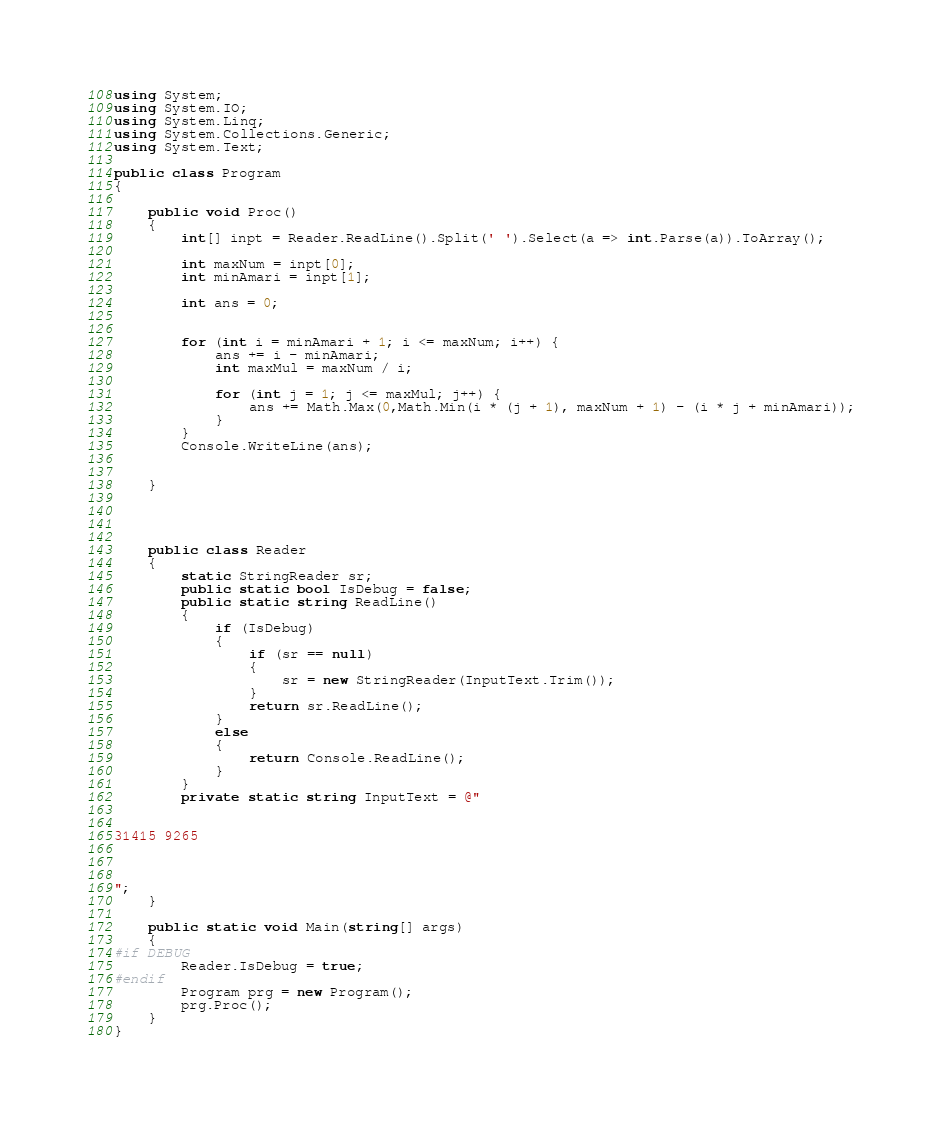<code> <loc_0><loc_0><loc_500><loc_500><_C#_>using System;
using System.IO;
using System.Linq;
using System.Collections.Generic;
using System.Text;

public class Program
{

    public void Proc()
    {
        int[] inpt = Reader.ReadLine().Split(' ').Select(a => int.Parse(a)).ToArray();

        int maxNum = inpt[0];
        int minAmari = inpt[1];

        int ans = 0;


        for (int i = minAmari + 1; i <= maxNum; i++) {
            ans += i - minAmari;
            int maxMul = maxNum / i;

            for (int j = 1; j <= maxMul; j++) {
                ans += Math.Max(0,Math.Min(i * (j + 1), maxNum + 1) - (i * j + minAmari));
            }
        }
        Console.WriteLine(ans);
    
    
    }




    public class Reader
    {
        static StringReader sr;
        public static bool IsDebug = false;
        public static string ReadLine()
        {
            if (IsDebug)
            {
                if (sr == null)
                {
                    sr = new StringReader(InputText.Trim());
                }
                return sr.ReadLine();
            }
            else
            {
                return Console.ReadLine();
            }
        }
        private static string InputText = @"


31415 9265



";
    }

    public static void Main(string[] args)
    {
#if DEBUG
        Reader.IsDebug = true;
#endif
        Program prg = new Program();
        prg.Proc();
    }
}
</code> 